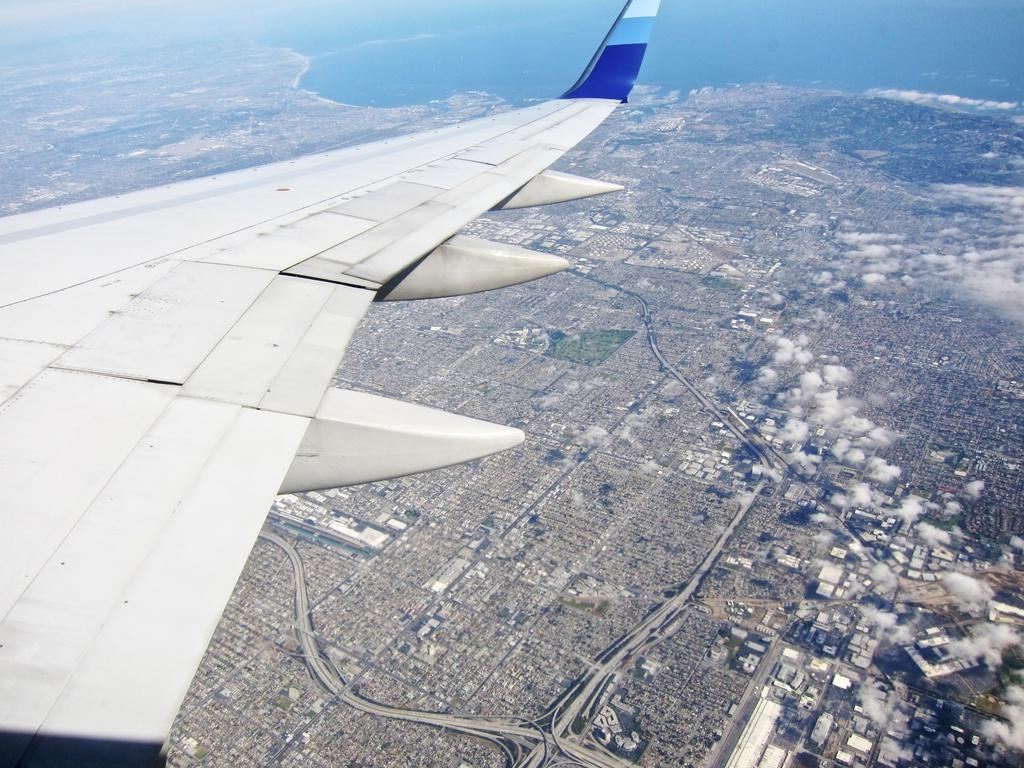What is the main subject of the image? The main subject of the image is an airplane wing. Where is the airplane wing located in the image? The airplane wing is in the air. What can be seen in the background of the image? There is sky and water visible in the background of the image. What type of leather is used to make the cherry-colored button in the image? There is no leather, cherry, or button present in the image. 